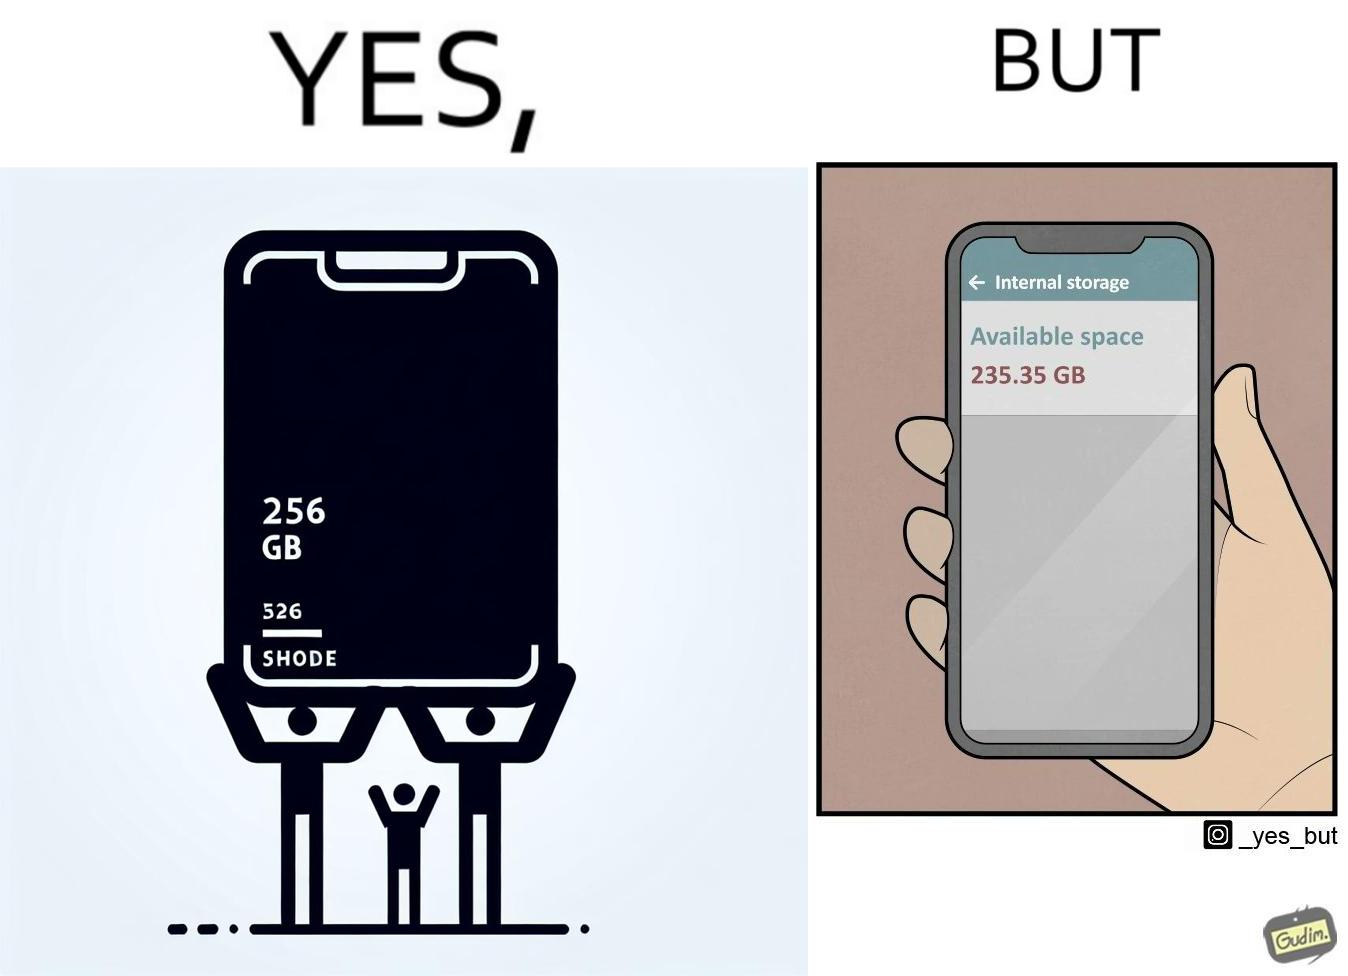What is shown in the left half versus the right half of this image? In the left part of the image: It is a smartphone box claiming the phone has a storage capacity of 256 gb In the right part of the image: It is a smartphone with 235.35 gb of available space 